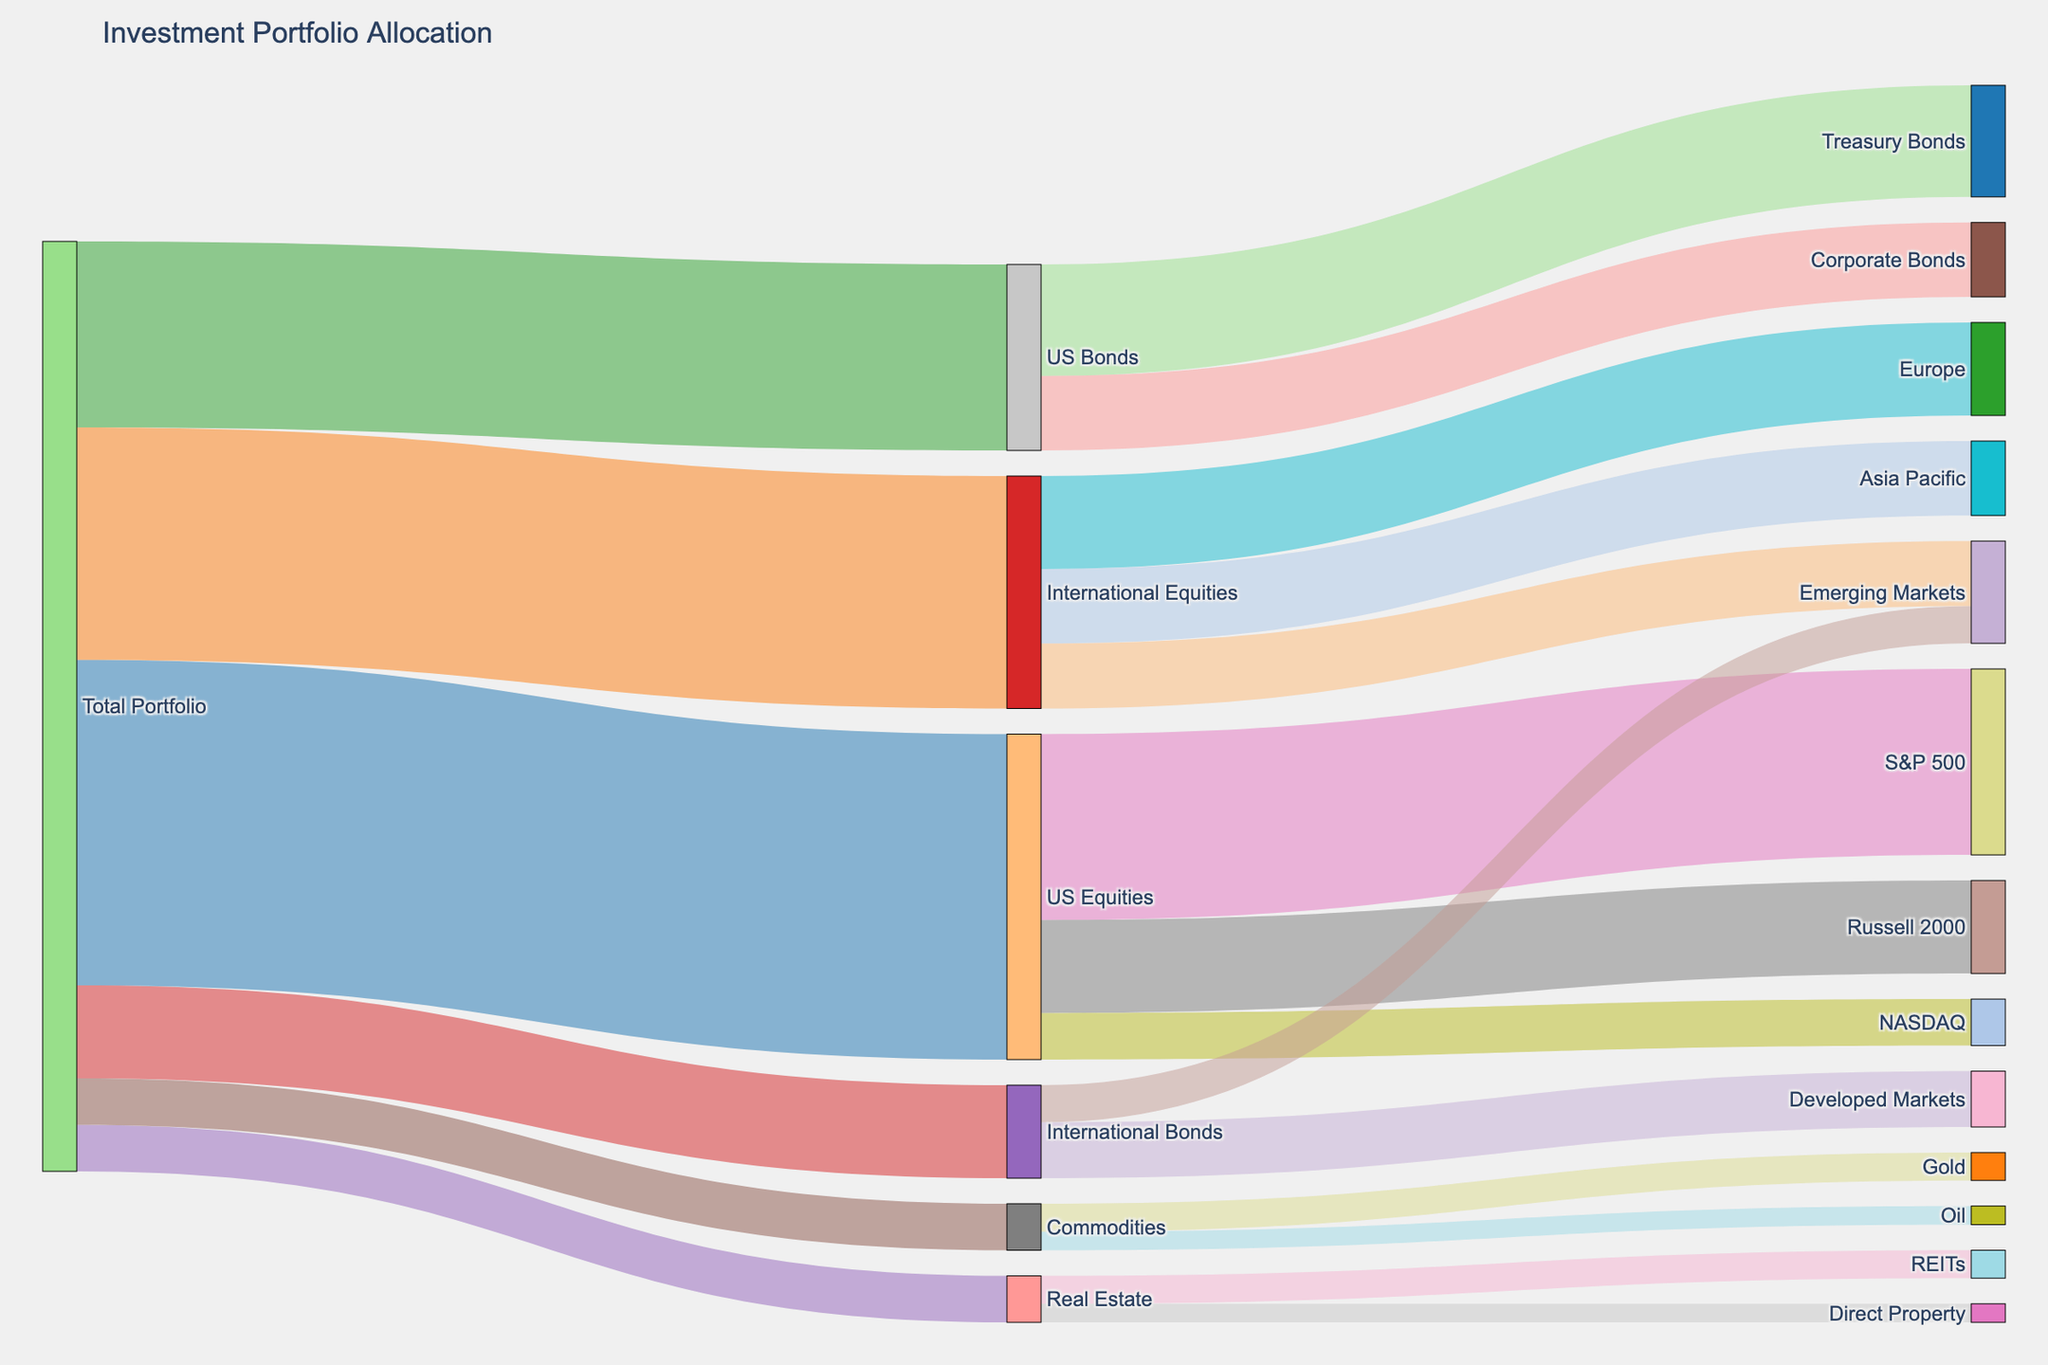What is the title of the Sankey diagram? The title is usually located at the top of the figure and summarizes what the diagram is about. In this case, it should be "Investment Portfolio Allocation".
Answer: Investment Portfolio Allocation How much of the total portfolio is allocated to US Equities? Look at the segment from "Total Portfolio" leading to "US Equities" and check the value associated with that link.
Answer: 35 Which asset class has the smallest allocation from the total portfolio? Compare all the values linked from "Total Portfolio" to different asset classes and find the smallest one.
Answer: Real Estate and Commodities What is the combined allocation for US and International Bonds? Sum the values of "US Bonds" and "International Bonds" from the "Total Portfolio". In this case, it’s 20 (US Bonds) + 10 (International Bonds).
Answer: 30 Which geographical region has the highest allocation within International Equities? Compare the values for the regions under "International Equities": Europe, Asia Pacific, and Emerging Markets.
Answer: Europe How much of the US Equities is allocated to the S&P 500? Look at the segment from "US Equities" leading to "S&P 500" and check the value associated with that link.
Answer: 20 Is more of the portfolio allocated to International Equities or US Bonds? Compare the values allocated to "International Equities" and "US Bonds".
Answer: International Equities What fraction of the total portfolio is allocated to Real Estate? The fraction can be calculated by taking the Real Estate allocation and dividing it by the total portfolio. Here, it’s 5 out of 100 or 5%.
Answer: 5% Which asset within Real Estate has the higher allocation? Compare the values under "Real Estate" for "REITs" and "Direct Property".
Answer: REITs What is the total value allocated to Commodities and their subcategories? Add the values of "Gold" and "Oil" under "Commodities". In this case, it’s 3 (Gold) + 2 (Oil).
Answer: 5 